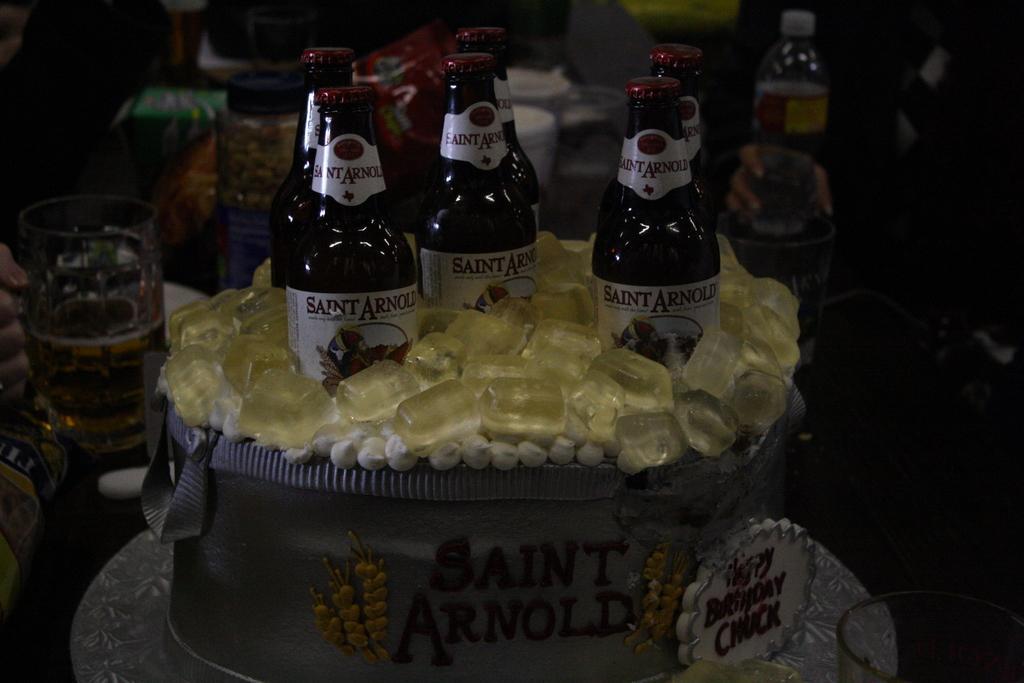In one or two sentences, can you explain what this image depicts? There are six beer bottles placed in a bag labelled as "saint Arnold. There is art representing ice around the beer bottle. There are few glasses and bottles in the background. 